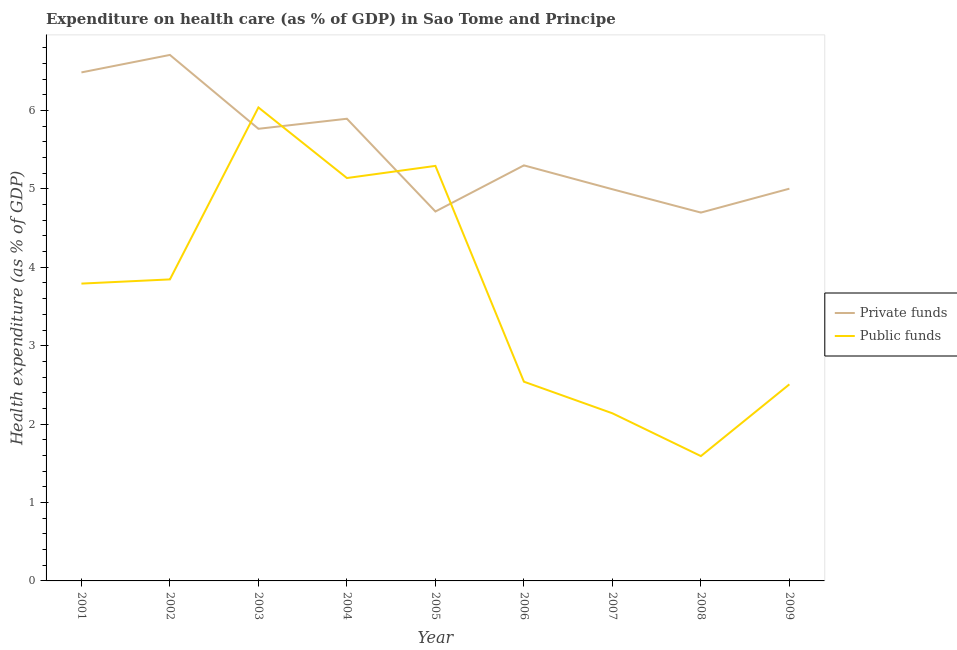How many different coloured lines are there?
Provide a succinct answer. 2. What is the amount of private funds spent in healthcare in 2007?
Your answer should be compact. 5. Across all years, what is the maximum amount of private funds spent in healthcare?
Your answer should be very brief. 6.71. Across all years, what is the minimum amount of private funds spent in healthcare?
Ensure brevity in your answer.  4.7. In which year was the amount of private funds spent in healthcare minimum?
Ensure brevity in your answer.  2008. What is the total amount of private funds spent in healthcare in the graph?
Keep it short and to the point. 49.56. What is the difference between the amount of private funds spent in healthcare in 2001 and that in 2005?
Ensure brevity in your answer.  1.77. What is the difference between the amount of private funds spent in healthcare in 2002 and the amount of public funds spent in healthcare in 2005?
Provide a short and direct response. 1.42. What is the average amount of public funds spent in healthcare per year?
Keep it short and to the point. 3.65. In the year 2006, what is the difference between the amount of public funds spent in healthcare and amount of private funds spent in healthcare?
Provide a succinct answer. -2.76. In how many years, is the amount of private funds spent in healthcare greater than 5.2 %?
Provide a succinct answer. 5. What is the ratio of the amount of public funds spent in healthcare in 2002 to that in 2005?
Give a very brief answer. 0.73. Is the amount of private funds spent in healthcare in 2002 less than that in 2008?
Provide a succinct answer. No. Is the difference between the amount of private funds spent in healthcare in 2002 and 2003 greater than the difference between the amount of public funds spent in healthcare in 2002 and 2003?
Offer a very short reply. Yes. What is the difference between the highest and the second highest amount of public funds spent in healthcare?
Provide a short and direct response. 0.75. What is the difference between the highest and the lowest amount of private funds spent in healthcare?
Provide a short and direct response. 2.01. Is the sum of the amount of public funds spent in healthcare in 2005 and 2006 greater than the maximum amount of private funds spent in healthcare across all years?
Give a very brief answer. Yes. Does the amount of private funds spent in healthcare monotonically increase over the years?
Ensure brevity in your answer.  No. Is the amount of public funds spent in healthcare strictly greater than the amount of private funds spent in healthcare over the years?
Your response must be concise. No. Is the amount of public funds spent in healthcare strictly less than the amount of private funds spent in healthcare over the years?
Offer a very short reply. No. Does the graph contain grids?
Give a very brief answer. No. What is the title of the graph?
Provide a short and direct response. Expenditure on health care (as % of GDP) in Sao Tome and Principe. What is the label or title of the X-axis?
Ensure brevity in your answer.  Year. What is the label or title of the Y-axis?
Provide a short and direct response. Health expenditure (as % of GDP). What is the Health expenditure (as % of GDP) in Private funds in 2001?
Provide a succinct answer. 6.49. What is the Health expenditure (as % of GDP) of Public funds in 2001?
Provide a short and direct response. 3.79. What is the Health expenditure (as % of GDP) in Private funds in 2002?
Your answer should be very brief. 6.71. What is the Health expenditure (as % of GDP) in Public funds in 2002?
Offer a very short reply. 3.85. What is the Health expenditure (as % of GDP) in Private funds in 2003?
Your answer should be compact. 5.77. What is the Health expenditure (as % of GDP) in Public funds in 2003?
Your answer should be very brief. 6.04. What is the Health expenditure (as % of GDP) of Private funds in 2004?
Provide a short and direct response. 5.89. What is the Health expenditure (as % of GDP) of Public funds in 2004?
Your response must be concise. 5.14. What is the Health expenditure (as % of GDP) in Private funds in 2005?
Provide a succinct answer. 4.71. What is the Health expenditure (as % of GDP) of Public funds in 2005?
Give a very brief answer. 5.29. What is the Health expenditure (as % of GDP) of Private funds in 2006?
Your response must be concise. 5.3. What is the Health expenditure (as % of GDP) in Public funds in 2006?
Provide a short and direct response. 2.54. What is the Health expenditure (as % of GDP) of Private funds in 2007?
Your answer should be compact. 5. What is the Health expenditure (as % of GDP) in Public funds in 2007?
Your answer should be compact. 2.14. What is the Health expenditure (as % of GDP) in Private funds in 2008?
Offer a terse response. 4.7. What is the Health expenditure (as % of GDP) of Public funds in 2008?
Keep it short and to the point. 1.59. What is the Health expenditure (as % of GDP) in Private funds in 2009?
Keep it short and to the point. 5. What is the Health expenditure (as % of GDP) of Public funds in 2009?
Make the answer very short. 2.51. Across all years, what is the maximum Health expenditure (as % of GDP) of Private funds?
Offer a terse response. 6.71. Across all years, what is the maximum Health expenditure (as % of GDP) of Public funds?
Ensure brevity in your answer.  6.04. Across all years, what is the minimum Health expenditure (as % of GDP) in Private funds?
Your answer should be compact. 4.7. Across all years, what is the minimum Health expenditure (as % of GDP) in Public funds?
Make the answer very short. 1.59. What is the total Health expenditure (as % of GDP) of Private funds in the graph?
Provide a succinct answer. 49.56. What is the total Health expenditure (as % of GDP) of Public funds in the graph?
Give a very brief answer. 32.89. What is the difference between the Health expenditure (as % of GDP) of Private funds in 2001 and that in 2002?
Provide a short and direct response. -0.22. What is the difference between the Health expenditure (as % of GDP) in Public funds in 2001 and that in 2002?
Your answer should be compact. -0.05. What is the difference between the Health expenditure (as % of GDP) in Private funds in 2001 and that in 2003?
Provide a succinct answer. 0.72. What is the difference between the Health expenditure (as % of GDP) of Public funds in 2001 and that in 2003?
Give a very brief answer. -2.25. What is the difference between the Health expenditure (as % of GDP) of Private funds in 2001 and that in 2004?
Offer a terse response. 0.59. What is the difference between the Health expenditure (as % of GDP) of Public funds in 2001 and that in 2004?
Ensure brevity in your answer.  -1.35. What is the difference between the Health expenditure (as % of GDP) in Private funds in 2001 and that in 2005?
Offer a very short reply. 1.77. What is the difference between the Health expenditure (as % of GDP) in Public funds in 2001 and that in 2005?
Keep it short and to the point. -1.5. What is the difference between the Health expenditure (as % of GDP) of Private funds in 2001 and that in 2006?
Make the answer very short. 1.19. What is the difference between the Health expenditure (as % of GDP) in Public funds in 2001 and that in 2006?
Give a very brief answer. 1.25. What is the difference between the Health expenditure (as % of GDP) in Private funds in 2001 and that in 2007?
Offer a very short reply. 1.49. What is the difference between the Health expenditure (as % of GDP) of Public funds in 2001 and that in 2007?
Keep it short and to the point. 1.65. What is the difference between the Health expenditure (as % of GDP) in Private funds in 2001 and that in 2008?
Offer a terse response. 1.79. What is the difference between the Health expenditure (as % of GDP) in Public funds in 2001 and that in 2008?
Give a very brief answer. 2.2. What is the difference between the Health expenditure (as % of GDP) in Private funds in 2001 and that in 2009?
Offer a very short reply. 1.48. What is the difference between the Health expenditure (as % of GDP) in Public funds in 2001 and that in 2009?
Your answer should be very brief. 1.28. What is the difference between the Health expenditure (as % of GDP) in Private funds in 2002 and that in 2003?
Your answer should be compact. 0.94. What is the difference between the Health expenditure (as % of GDP) of Public funds in 2002 and that in 2003?
Provide a succinct answer. -2.19. What is the difference between the Health expenditure (as % of GDP) of Private funds in 2002 and that in 2004?
Your response must be concise. 0.81. What is the difference between the Health expenditure (as % of GDP) of Public funds in 2002 and that in 2004?
Provide a short and direct response. -1.29. What is the difference between the Health expenditure (as % of GDP) of Private funds in 2002 and that in 2005?
Your response must be concise. 2. What is the difference between the Health expenditure (as % of GDP) of Public funds in 2002 and that in 2005?
Your answer should be very brief. -1.45. What is the difference between the Health expenditure (as % of GDP) of Private funds in 2002 and that in 2006?
Make the answer very short. 1.41. What is the difference between the Health expenditure (as % of GDP) of Public funds in 2002 and that in 2006?
Offer a very short reply. 1.3. What is the difference between the Health expenditure (as % of GDP) of Private funds in 2002 and that in 2007?
Your answer should be compact. 1.71. What is the difference between the Health expenditure (as % of GDP) in Public funds in 2002 and that in 2007?
Your answer should be very brief. 1.71. What is the difference between the Health expenditure (as % of GDP) in Private funds in 2002 and that in 2008?
Make the answer very short. 2.01. What is the difference between the Health expenditure (as % of GDP) in Public funds in 2002 and that in 2008?
Make the answer very short. 2.25. What is the difference between the Health expenditure (as % of GDP) in Private funds in 2002 and that in 2009?
Offer a very short reply. 1.71. What is the difference between the Health expenditure (as % of GDP) of Public funds in 2002 and that in 2009?
Ensure brevity in your answer.  1.34. What is the difference between the Health expenditure (as % of GDP) of Private funds in 2003 and that in 2004?
Provide a short and direct response. -0.13. What is the difference between the Health expenditure (as % of GDP) in Public funds in 2003 and that in 2004?
Make the answer very short. 0.9. What is the difference between the Health expenditure (as % of GDP) in Private funds in 2003 and that in 2005?
Make the answer very short. 1.05. What is the difference between the Health expenditure (as % of GDP) in Public funds in 2003 and that in 2005?
Your response must be concise. 0.75. What is the difference between the Health expenditure (as % of GDP) in Private funds in 2003 and that in 2006?
Provide a short and direct response. 0.47. What is the difference between the Health expenditure (as % of GDP) of Public funds in 2003 and that in 2006?
Ensure brevity in your answer.  3.5. What is the difference between the Health expenditure (as % of GDP) in Private funds in 2003 and that in 2007?
Give a very brief answer. 0.77. What is the difference between the Health expenditure (as % of GDP) of Public funds in 2003 and that in 2007?
Provide a short and direct response. 3.9. What is the difference between the Health expenditure (as % of GDP) in Private funds in 2003 and that in 2008?
Give a very brief answer. 1.07. What is the difference between the Health expenditure (as % of GDP) in Public funds in 2003 and that in 2008?
Your answer should be compact. 4.45. What is the difference between the Health expenditure (as % of GDP) of Private funds in 2003 and that in 2009?
Offer a terse response. 0.76. What is the difference between the Health expenditure (as % of GDP) in Public funds in 2003 and that in 2009?
Your response must be concise. 3.53. What is the difference between the Health expenditure (as % of GDP) in Private funds in 2004 and that in 2005?
Your response must be concise. 1.18. What is the difference between the Health expenditure (as % of GDP) in Public funds in 2004 and that in 2005?
Your answer should be very brief. -0.15. What is the difference between the Health expenditure (as % of GDP) of Private funds in 2004 and that in 2006?
Give a very brief answer. 0.59. What is the difference between the Health expenditure (as % of GDP) of Public funds in 2004 and that in 2006?
Your response must be concise. 2.6. What is the difference between the Health expenditure (as % of GDP) in Private funds in 2004 and that in 2007?
Your answer should be compact. 0.9. What is the difference between the Health expenditure (as % of GDP) in Public funds in 2004 and that in 2007?
Provide a short and direct response. 3. What is the difference between the Health expenditure (as % of GDP) of Private funds in 2004 and that in 2008?
Provide a succinct answer. 1.2. What is the difference between the Health expenditure (as % of GDP) of Public funds in 2004 and that in 2008?
Provide a succinct answer. 3.55. What is the difference between the Health expenditure (as % of GDP) in Private funds in 2004 and that in 2009?
Your answer should be compact. 0.89. What is the difference between the Health expenditure (as % of GDP) of Public funds in 2004 and that in 2009?
Ensure brevity in your answer.  2.63. What is the difference between the Health expenditure (as % of GDP) of Private funds in 2005 and that in 2006?
Your answer should be compact. -0.59. What is the difference between the Health expenditure (as % of GDP) in Public funds in 2005 and that in 2006?
Your response must be concise. 2.75. What is the difference between the Health expenditure (as % of GDP) in Private funds in 2005 and that in 2007?
Provide a succinct answer. -0.28. What is the difference between the Health expenditure (as % of GDP) of Public funds in 2005 and that in 2007?
Offer a terse response. 3.16. What is the difference between the Health expenditure (as % of GDP) in Private funds in 2005 and that in 2008?
Your answer should be compact. 0.01. What is the difference between the Health expenditure (as % of GDP) of Public funds in 2005 and that in 2008?
Your answer should be very brief. 3.7. What is the difference between the Health expenditure (as % of GDP) of Private funds in 2005 and that in 2009?
Provide a short and direct response. -0.29. What is the difference between the Health expenditure (as % of GDP) of Public funds in 2005 and that in 2009?
Your answer should be very brief. 2.79. What is the difference between the Health expenditure (as % of GDP) in Private funds in 2006 and that in 2007?
Offer a very short reply. 0.3. What is the difference between the Health expenditure (as % of GDP) of Public funds in 2006 and that in 2007?
Provide a succinct answer. 0.4. What is the difference between the Health expenditure (as % of GDP) of Private funds in 2006 and that in 2008?
Provide a short and direct response. 0.6. What is the difference between the Health expenditure (as % of GDP) in Public funds in 2006 and that in 2008?
Offer a terse response. 0.95. What is the difference between the Health expenditure (as % of GDP) of Private funds in 2006 and that in 2009?
Your response must be concise. 0.3. What is the difference between the Health expenditure (as % of GDP) in Public funds in 2006 and that in 2009?
Ensure brevity in your answer.  0.03. What is the difference between the Health expenditure (as % of GDP) in Private funds in 2007 and that in 2008?
Your response must be concise. 0.3. What is the difference between the Health expenditure (as % of GDP) in Public funds in 2007 and that in 2008?
Offer a terse response. 0.55. What is the difference between the Health expenditure (as % of GDP) in Private funds in 2007 and that in 2009?
Offer a very short reply. -0.01. What is the difference between the Health expenditure (as % of GDP) of Public funds in 2007 and that in 2009?
Your answer should be compact. -0.37. What is the difference between the Health expenditure (as % of GDP) in Private funds in 2008 and that in 2009?
Provide a succinct answer. -0.3. What is the difference between the Health expenditure (as % of GDP) in Public funds in 2008 and that in 2009?
Offer a terse response. -0.92. What is the difference between the Health expenditure (as % of GDP) in Private funds in 2001 and the Health expenditure (as % of GDP) in Public funds in 2002?
Offer a very short reply. 2.64. What is the difference between the Health expenditure (as % of GDP) in Private funds in 2001 and the Health expenditure (as % of GDP) in Public funds in 2003?
Your response must be concise. 0.45. What is the difference between the Health expenditure (as % of GDP) of Private funds in 2001 and the Health expenditure (as % of GDP) of Public funds in 2004?
Your answer should be compact. 1.35. What is the difference between the Health expenditure (as % of GDP) in Private funds in 2001 and the Health expenditure (as % of GDP) in Public funds in 2005?
Your answer should be compact. 1.19. What is the difference between the Health expenditure (as % of GDP) in Private funds in 2001 and the Health expenditure (as % of GDP) in Public funds in 2006?
Make the answer very short. 3.94. What is the difference between the Health expenditure (as % of GDP) in Private funds in 2001 and the Health expenditure (as % of GDP) in Public funds in 2007?
Your answer should be compact. 4.35. What is the difference between the Health expenditure (as % of GDP) of Private funds in 2001 and the Health expenditure (as % of GDP) of Public funds in 2008?
Give a very brief answer. 4.89. What is the difference between the Health expenditure (as % of GDP) in Private funds in 2001 and the Health expenditure (as % of GDP) in Public funds in 2009?
Give a very brief answer. 3.98. What is the difference between the Health expenditure (as % of GDP) in Private funds in 2002 and the Health expenditure (as % of GDP) in Public funds in 2003?
Your answer should be very brief. 0.67. What is the difference between the Health expenditure (as % of GDP) of Private funds in 2002 and the Health expenditure (as % of GDP) of Public funds in 2004?
Offer a very short reply. 1.57. What is the difference between the Health expenditure (as % of GDP) in Private funds in 2002 and the Health expenditure (as % of GDP) in Public funds in 2005?
Provide a short and direct response. 1.42. What is the difference between the Health expenditure (as % of GDP) in Private funds in 2002 and the Health expenditure (as % of GDP) in Public funds in 2006?
Your answer should be very brief. 4.17. What is the difference between the Health expenditure (as % of GDP) of Private funds in 2002 and the Health expenditure (as % of GDP) of Public funds in 2007?
Your answer should be very brief. 4.57. What is the difference between the Health expenditure (as % of GDP) in Private funds in 2002 and the Health expenditure (as % of GDP) in Public funds in 2008?
Your answer should be compact. 5.12. What is the difference between the Health expenditure (as % of GDP) in Private funds in 2002 and the Health expenditure (as % of GDP) in Public funds in 2009?
Provide a short and direct response. 4.2. What is the difference between the Health expenditure (as % of GDP) of Private funds in 2003 and the Health expenditure (as % of GDP) of Public funds in 2004?
Ensure brevity in your answer.  0.63. What is the difference between the Health expenditure (as % of GDP) in Private funds in 2003 and the Health expenditure (as % of GDP) in Public funds in 2005?
Your answer should be compact. 0.47. What is the difference between the Health expenditure (as % of GDP) in Private funds in 2003 and the Health expenditure (as % of GDP) in Public funds in 2006?
Ensure brevity in your answer.  3.23. What is the difference between the Health expenditure (as % of GDP) in Private funds in 2003 and the Health expenditure (as % of GDP) in Public funds in 2007?
Keep it short and to the point. 3.63. What is the difference between the Health expenditure (as % of GDP) of Private funds in 2003 and the Health expenditure (as % of GDP) of Public funds in 2008?
Your answer should be very brief. 4.17. What is the difference between the Health expenditure (as % of GDP) of Private funds in 2003 and the Health expenditure (as % of GDP) of Public funds in 2009?
Provide a short and direct response. 3.26. What is the difference between the Health expenditure (as % of GDP) of Private funds in 2004 and the Health expenditure (as % of GDP) of Public funds in 2005?
Your answer should be compact. 0.6. What is the difference between the Health expenditure (as % of GDP) of Private funds in 2004 and the Health expenditure (as % of GDP) of Public funds in 2006?
Make the answer very short. 3.35. What is the difference between the Health expenditure (as % of GDP) in Private funds in 2004 and the Health expenditure (as % of GDP) in Public funds in 2007?
Keep it short and to the point. 3.76. What is the difference between the Health expenditure (as % of GDP) of Private funds in 2004 and the Health expenditure (as % of GDP) of Public funds in 2008?
Your answer should be very brief. 4.3. What is the difference between the Health expenditure (as % of GDP) in Private funds in 2004 and the Health expenditure (as % of GDP) in Public funds in 2009?
Provide a succinct answer. 3.39. What is the difference between the Health expenditure (as % of GDP) in Private funds in 2005 and the Health expenditure (as % of GDP) in Public funds in 2006?
Provide a succinct answer. 2.17. What is the difference between the Health expenditure (as % of GDP) of Private funds in 2005 and the Health expenditure (as % of GDP) of Public funds in 2007?
Offer a terse response. 2.57. What is the difference between the Health expenditure (as % of GDP) of Private funds in 2005 and the Health expenditure (as % of GDP) of Public funds in 2008?
Keep it short and to the point. 3.12. What is the difference between the Health expenditure (as % of GDP) of Private funds in 2005 and the Health expenditure (as % of GDP) of Public funds in 2009?
Offer a terse response. 2.2. What is the difference between the Health expenditure (as % of GDP) of Private funds in 2006 and the Health expenditure (as % of GDP) of Public funds in 2007?
Your answer should be very brief. 3.16. What is the difference between the Health expenditure (as % of GDP) in Private funds in 2006 and the Health expenditure (as % of GDP) in Public funds in 2008?
Offer a terse response. 3.71. What is the difference between the Health expenditure (as % of GDP) in Private funds in 2006 and the Health expenditure (as % of GDP) in Public funds in 2009?
Ensure brevity in your answer.  2.79. What is the difference between the Health expenditure (as % of GDP) in Private funds in 2007 and the Health expenditure (as % of GDP) in Public funds in 2008?
Your answer should be compact. 3.4. What is the difference between the Health expenditure (as % of GDP) in Private funds in 2007 and the Health expenditure (as % of GDP) in Public funds in 2009?
Keep it short and to the point. 2.49. What is the difference between the Health expenditure (as % of GDP) of Private funds in 2008 and the Health expenditure (as % of GDP) of Public funds in 2009?
Make the answer very short. 2.19. What is the average Health expenditure (as % of GDP) of Private funds per year?
Provide a short and direct response. 5.51. What is the average Health expenditure (as % of GDP) in Public funds per year?
Your answer should be compact. 3.65. In the year 2001, what is the difference between the Health expenditure (as % of GDP) of Private funds and Health expenditure (as % of GDP) of Public funds?
Keep it short and to the point. 2.69. In the year 2002, what is the difference between the Health expenditure (as % of GDP) of Private funds and Health expenditure (as % of GDP) of Public funds?
Your answer should be very brief. 2.86. In the year 2003, what is the difference between the Health expenditure (as % of GDP) in Private funds and Health expenditure (as % of GDP) in Public funds?
Keep it short and to the point. -0.27. In the year 2004, what is the difference between the Health expenditure (as % of GDP) of Private funds and Health expenditure (as % of GDP) of Public funds?
Keep it short and to the point. 0.76. In the year 2005, what is the difference between the Health expenditure (as % of GDP) of Private funds and Health expenditure (as % of GDP) of Public funds?
Your response must be concise. -0.58. In the year 2006, what is the difference between the Health expenditure (as % of GDP) of Private funds and Health expenditure (as % of GDP) of Public funds?
Provide a short and direct response. 2.76. In the year 2007, what is the difference between the Health expenditure (as % of GDP) of Private funds and Health expenditure (as % of GDP) of Public funds?
Offer a terse response. 2.86. In the year 2008, what is the difference between the Health expenditure (as % of GDP) in Private funds and Health expenditure (as % of GDP) in Public funds?
Offer a terse response. 3.11. In the year 2009, what is the difference between the Health expenditure (as % of GDP) of Private funds and Health expenditure (as % of GDP) of Public funds?
Offer a very short reply. 2.5. What is the ratio of the Health expenditure (as % of GDP) of Private funds in 2001 to that in 2002?
Make the answer very short. 0.97. What is the ratio of the Health expenditure (as % of GDP) in Public funds in 2001 to that in 2002?
Keep it short and to the point. 0.99. What is the ratio of the Health expenditure (as % of GDP) in Private funds in 2001 to that in 2003?
Offer a terse response. 1.12. What is the ratio of the Health expenditure (as % of GDP) in Public funds in 2001 to that in 2003?
Keep it short and to the point. 0.63. What is the ratio of the Health expenditure (as % of GDP) of Private funds in 2001 to that in 2004?
Make the answer very short. 1.1. What is the ratio of the Health expenditure (as % of GDP) in Public funds in 2001 to that in 2004?
Give a very brief answer. 0.74. What is the ratio of the Health expenditure (as % of GDP) in Private funds in 2001 to that in 2005?
Your response must be concise. 1.38. What is the ratio of the Health expenditure (as % of GDP) of Public funds in 2001 to that in 2005?
Make the answer very short. 0.72. What is the ratio of the Health expenditure (as % of GDP) in Private funds in 2001 to that in 2006?
Provide a succinct answer. 1.22. What is the ratio of the Health expenditure (as % of GDP) of Public funds in 2001 to that in 2006?
Provide a short and direct response. 1.49. What is the ratio of the Health expenditure (as % of GDP) of Private funds in 2001 to that in 2007?
Offer a very short reply. 1.3. What is the ratio of the Health expenditure (as % of GDP) of Public funds in 2001 to that in 2007?
Ensure brevity in your answer.  1.77. What is the ratio of the Health expenditure (as % of GDP) of Private funds in 2001 to that in 2008?
Ensure brevity in your answer.  1.38. What is the ratio of the Health expenditure (as % of GDP) in Public funds in 2001 to that in 2008?
Ensure brevity in your answer.  2.38. What is the ratio of the Health expenditure (as % of GDP) in Private funds in 2001 to that in 2009?
Give a very brief answer. 1.3. What is the ratio of the Health expenditure (as % of GDP) in Public funds in 2001 to that in 2009?
Provide a short and direct response. 1.51. What is the ratio of the Health expenditure (as % of GDP) of Private funds in 2002 to that in 2003?
Provide a succinct answer. 1.16. What is the ratio of the Health expenditure (as % of GDP) in Public funds in 2002 to that in 2003?
Make the answer very short. 0.64. What is the ratio of the Health expenditure (as % of GDP) in Private funds in 2002 to that in 2004?
Keep it short and to the point. 1.14. What is the ratio of the Health expenditure (as % of GDP) of Public funds in 2002 to that in 2004?
Offer a terse response. 0.75. What is the ratio of the Health expenditure (as % of GDP) of Private funds in 2002 to that in 2005?
Give a very brief answer. 1.42. What is the ratio of the Health expenditure (as % of GDP) in Public funds in 2002 to that in 2005?
Make the answer very short. 0.73. What is the ratio of the Health expenditure (as % of GDP) in Private funds in 2002 to that in 2006?
Keep it short and to the point. 1.27. What is the ratio of the Health expenditure (as % of GDP) in Public funds in 2002 to that in 2006?
Make the answer very short. 1.51. What is the ratio of the Health expenditure (as % of GDP) in Private funds in 2002 to that in 2007?
Your answer should be compact. 1.34. What is the ratio of the Health expenditure (as % of GDP) in Public funds in 2002 to that in 2007?
Your response must be concise. 1.8. What is the ratio of the Health expenditure (as % of GDP) in Private funds in 2002 to that in 2008?
Your response must be concise. 1.43. What is the ratio of the Health expenditure (as % of GDP) of Public funds in 2002 to that in 2008?
Provide a succinct answer. 2.42. What is the ratio of the Health expenditure (as % of GDP) of Private funds in 2002 to that in 2009?
Your answer should be very brief. 1.34. What is the ratio of the Health expenditure (as % of GDP) of Public funds in 2002 to that in 2009?
Ensure brevity in your answer.  1.53. What is the ratio of the Health expenditure (as % of GDP) in Private funds in 2003 to that in 2004?
Your answer should be very brief. 0.98. What is the ratio of the Health expenditure (as % of GDP) in Public funds in 2003 to that in 2004?
Your response must be concise. 1.18. What is the ratio of the Health expenditure (as % of GDP) in Private funds in 2003 to that in 2005?
Your answer should be very brief. 1.22. What is the ratio of the Health expenditure (as % of GDP) of Public funds in 2003 to that in 2005?
Your answer should be very brief. 1.14. What is the ratio of the Health expenditure (as % of GDP) in Private funds in 2003 to that in 2006?
Offer a terse response. 1.09. What is the ratio of the Health expenditure (as % of GDP) of Public funds in 2003 to that in 2006?
Provide a succinct answer. 2.38. What is the ratio of the Health expenditure (as % of GDP) in Private funds in 2003 to that in 2007?
Ensure brevity in your answer.  1.15. What is the ratio of the Health expenditure (as % of GDP) of Public funds in 2003 to that in 2007?
Make the answer very short. 2.82. What is the ratio of the Health expenditure (as % of GDP) of Private funds in 2003 to that in 2008?
Your answer should be very brief. 1.23. What is the ratio of the Health expenditure (as % of GDP) of Public funds in 2003 to that in 2008?
Your answer should be very brief. 3.79. What is the ratio of the Health expenditure (as % of GDP) in Private funds in 2003 to that in 2009?
Offer a terse response. 1.15. What is the ratio of the Health expenditure (as % of GDP) in Public funds in 2003 to that in 2009?
Offer a terse response. 2.41. What is the ratio of the Health expenditure (as % of GDP) of Private funds in 2004 to that in 2005?
Provide a succinct answer. 1.25. What is the ratio of the Health expenditure (as % of GDP) in Public funds in 2004 to that in 2005?
Ensure brevity in your answer.  0.97. What is the ratio of the Health expenditure (as % of GDP) in Private funds in 2004 to that in 2006?
Keep it short and to the point. 1.11. What is the ratio of the Health expenditure (as % of GDP) in Public funds in 2004 to that in 2006?
Provide a succinct answer. 2.02. What is the ratio of the Health expenditure (as % of GDP) of Private funds in 2004 to that in 2007?
Keep it short and to the point. 1.18. What is the ratio of the Health expenditure (as % of GDP) in Public funds in 2004 to that in 2007?
Your answer should be compact. 2.4. What is the ratio of the Health expenditure (as % of GDP) in Private funds in 2004 to that in 2008?
Offer a very short reply. 1.25. What is the ratio of the Health expenditure (as % of GDP) in Public funds in 2004 to that in 2008?
Ensure brevity in your answer.  3.23. What is the ratio of the Health expenditure (as % of GDP) in Private funds in 2004 to that in 2009?
Offer a terse response. 1.18. What is the ratio of the Health expenditure (as % of GDP) in Public funds in 2004 to that in 2009?
Make the answer very short. 2.05. What is the ratio of the Health expenditure (as % of GDP) in Private funds in 2005 to that in 2006?
Keep it short and to the point. 0.89. What is the ratio of the Health expenditure (as % of GDP) of Public funds in 2005 to that in 2006?
Provide a short and direct response. 2.08. What is the ratio of the Health expenditure (as % of GDP) in Private funds in 2005 to that in 2007?
Offer a very short reply. 0.94. What is the ratio of the Health expenditure (as % of GDP) of Public funds in 2005 to that in 2007?
Ensure brevity in your answer.  2.48. What is the ratio of the Health expenditure (as % of GDP) in Public funds in 2005 to that in 2008?
Keep it short and to the point. 3.32. What is the ratio of the Health expenditure (as % of GDP) in Private funds in 2005 to that in 2009?
Provide a short and direct response. 0.94. What is the ratio of the Health expenditure (as % of GDP) in Public funds in 2005 to that in 2009?
Give a very brief answer. 2.11. What is the ratio of the Health expenditure (as % of GDP) of Private funds in 2006 to that in 2007?
Offer a terse response. 1.06. What is the ratio of the Health expenditure (as % of GDP) in Public funds in 2006 to that in 2007?
Provide a short and direct response. 1.19. What is the ratio of the Health expenditure (as % of GDP) of Private funds in 2006 to that in 2008?
Your response must be concise. 1.13. What is the ratio of the Health expenditure (as % of GDP) of Public funds in 2006 to that in 2008?
Your response must be concise. 1.6. What is the ratio of the Health expenditure (as % of GDP) of Private funds in 2006 to that in 2009?
Offer a terse response. 1.06. What is the ratio of the Health expenditure (as % of GDP) of Public funds in 2006 to that in 2009?
Offer a terse response. 1.01. What is the ratio of the Health expenditure (as % of GDP) of Private funds in 2007 to that in 2008?
Make the answer very short. 1.06. What is the ratio of the Health expenditure (as % of GDP) of Public funds in 2007 to that in 2008?
Your response must be concise. 1.34. What is the ratio of the Health expenditure (as % of GDP) in Public funds in 2007 to that in 2009?
Your answer should be very brief. 0.85. What is the ratio of the Health expenditure (as % of GDP) of Private funds in 2008 to that in 2009?
Ensure brevity in your answer.  0.94. What is the ratio of the Health expenditure (as % of GDP) of Public funds in 2008 to that in 2009?
Provide a succinct answer. 0.64. What is the difference between the highest and the second highest Health expenditure (as % of GDP) of Private funds?
Offer a very short reply. 0.22. What is the difference between the highest and the second highest Health expenditure (as % of GDP) in Public funds?
Offer a very short reply. 0.75. What is the difference between the highest and the lowest Health expenditure (as % of GDP) of Private funds?
Your answer should be very brief. 2.01. What is the difference between the highest and the lowest Health expenditure (as % of GDP) of Public funds?
Offer a very short reply. 4.45. 